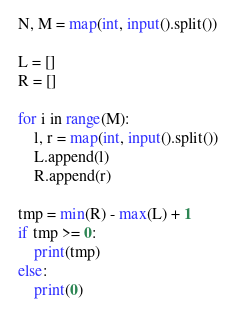Convert code to text. <code><loc_0><loc_0><loc_500><loc_500><_Python_>N, M = map(int, input().split())

L = []
R = []

for i in range(M):
    l, r = map(int, input().split())
    L.append(l)
    R.append(r)
    
tmp = min(R) - max(L) + 1
if tmp >= 0:
    print(tmp)
else:
    print(0)</code> 